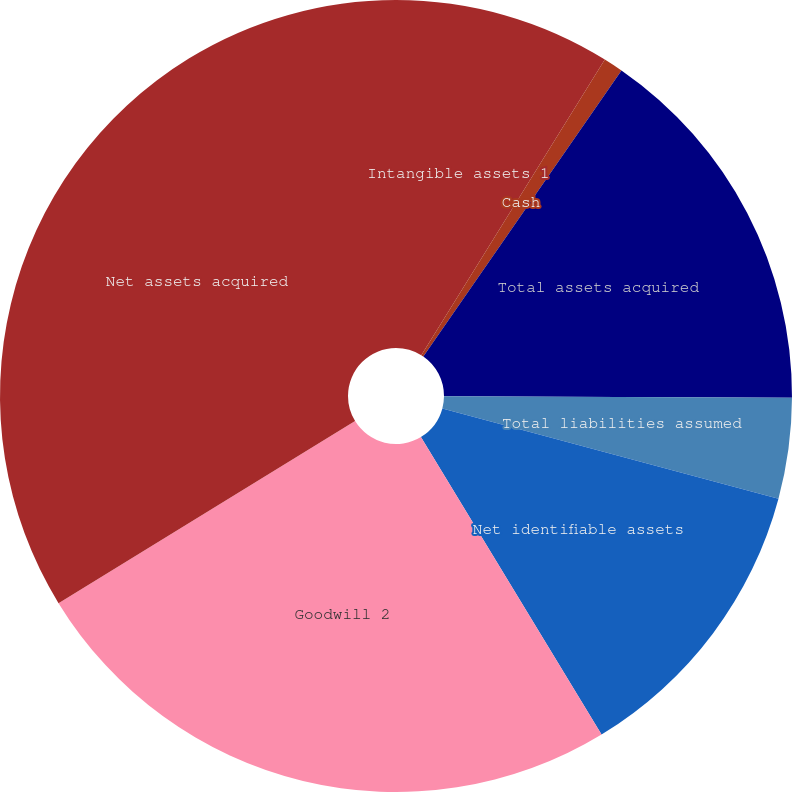Convert chart to OTSL. <chart><loc_0><loc_0><loc_500><loc_500><pie_chart><fcel>Intangible assets 1<fcel>Cash<fcel>Total assets acquired<fcel>Total liabilities assumed<fcel>Net identifiable assets<fcel>Goodwill 2<fcel>Net assets acquired<nl><fcel>8.84%<fcel>0.8%<fcel>15.43%<fcel>4.1%<fcel>12.14%<fcel>24.92%<fcel>33.76%<nl></chart> 